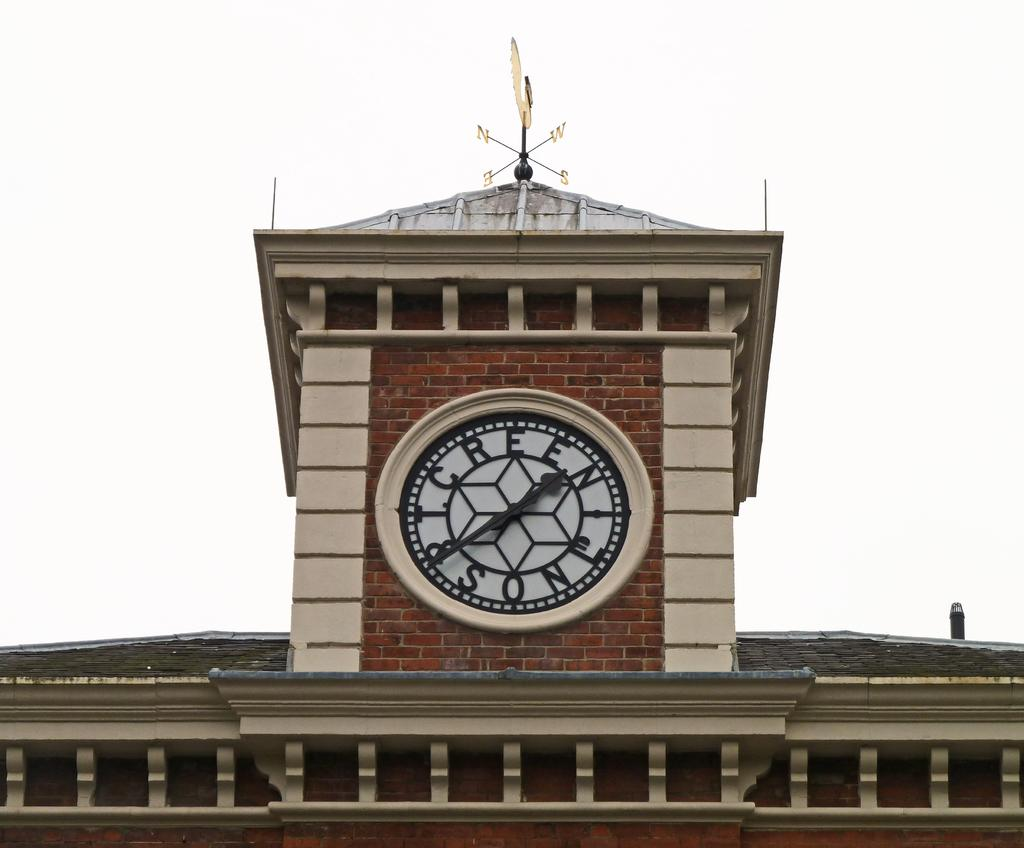<image>
Provide a brief description of the given image. A Large clock sits on a the top of a building with letters where the numbers would normally be. 